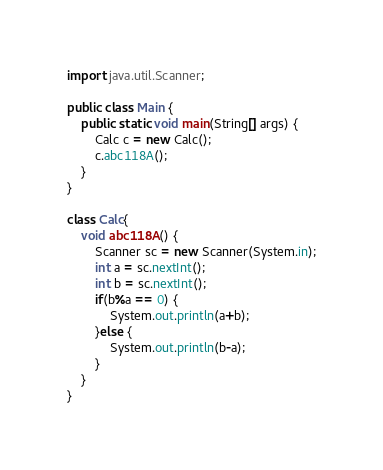<code> <loc_0><loc_0><loc_500><loc_500><_Java_>import java.util.Scanner;

public class Main {
	public static void main(String[] args) {
		Calc c = new Calc();
		c.abc118A();
	}
}

class Calc{
	void abc118A() {
		Scanner sc = new Scanner(System.in);
		int a = sc.nextInt();
		int b = sc.nextInt();
		if(b%a == 0) {
			System.out.println(a+b);
		}else {
			System.out.println(b-a);
		}
	}
}</code> 